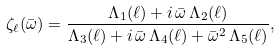<formula> <loc_0><loc_0><loc_500><loc_500>\zeta _ { \ell } ( \bar { \omega } ) = \frac { \Lambda _ { 1 } ( \ell ) + i \, \bar { \omega } \, \Lambda _ { 2 } ( \ell ) } { \Lambda _ { 3 } ( \ell ) + i \, \bar { \omega } \, \Lambda _ { 4 } ( \ell ) + \bar { \omega } ^ { 2 } \, \Lambda _ { 5 } ( \ell ) } ,</formula> 